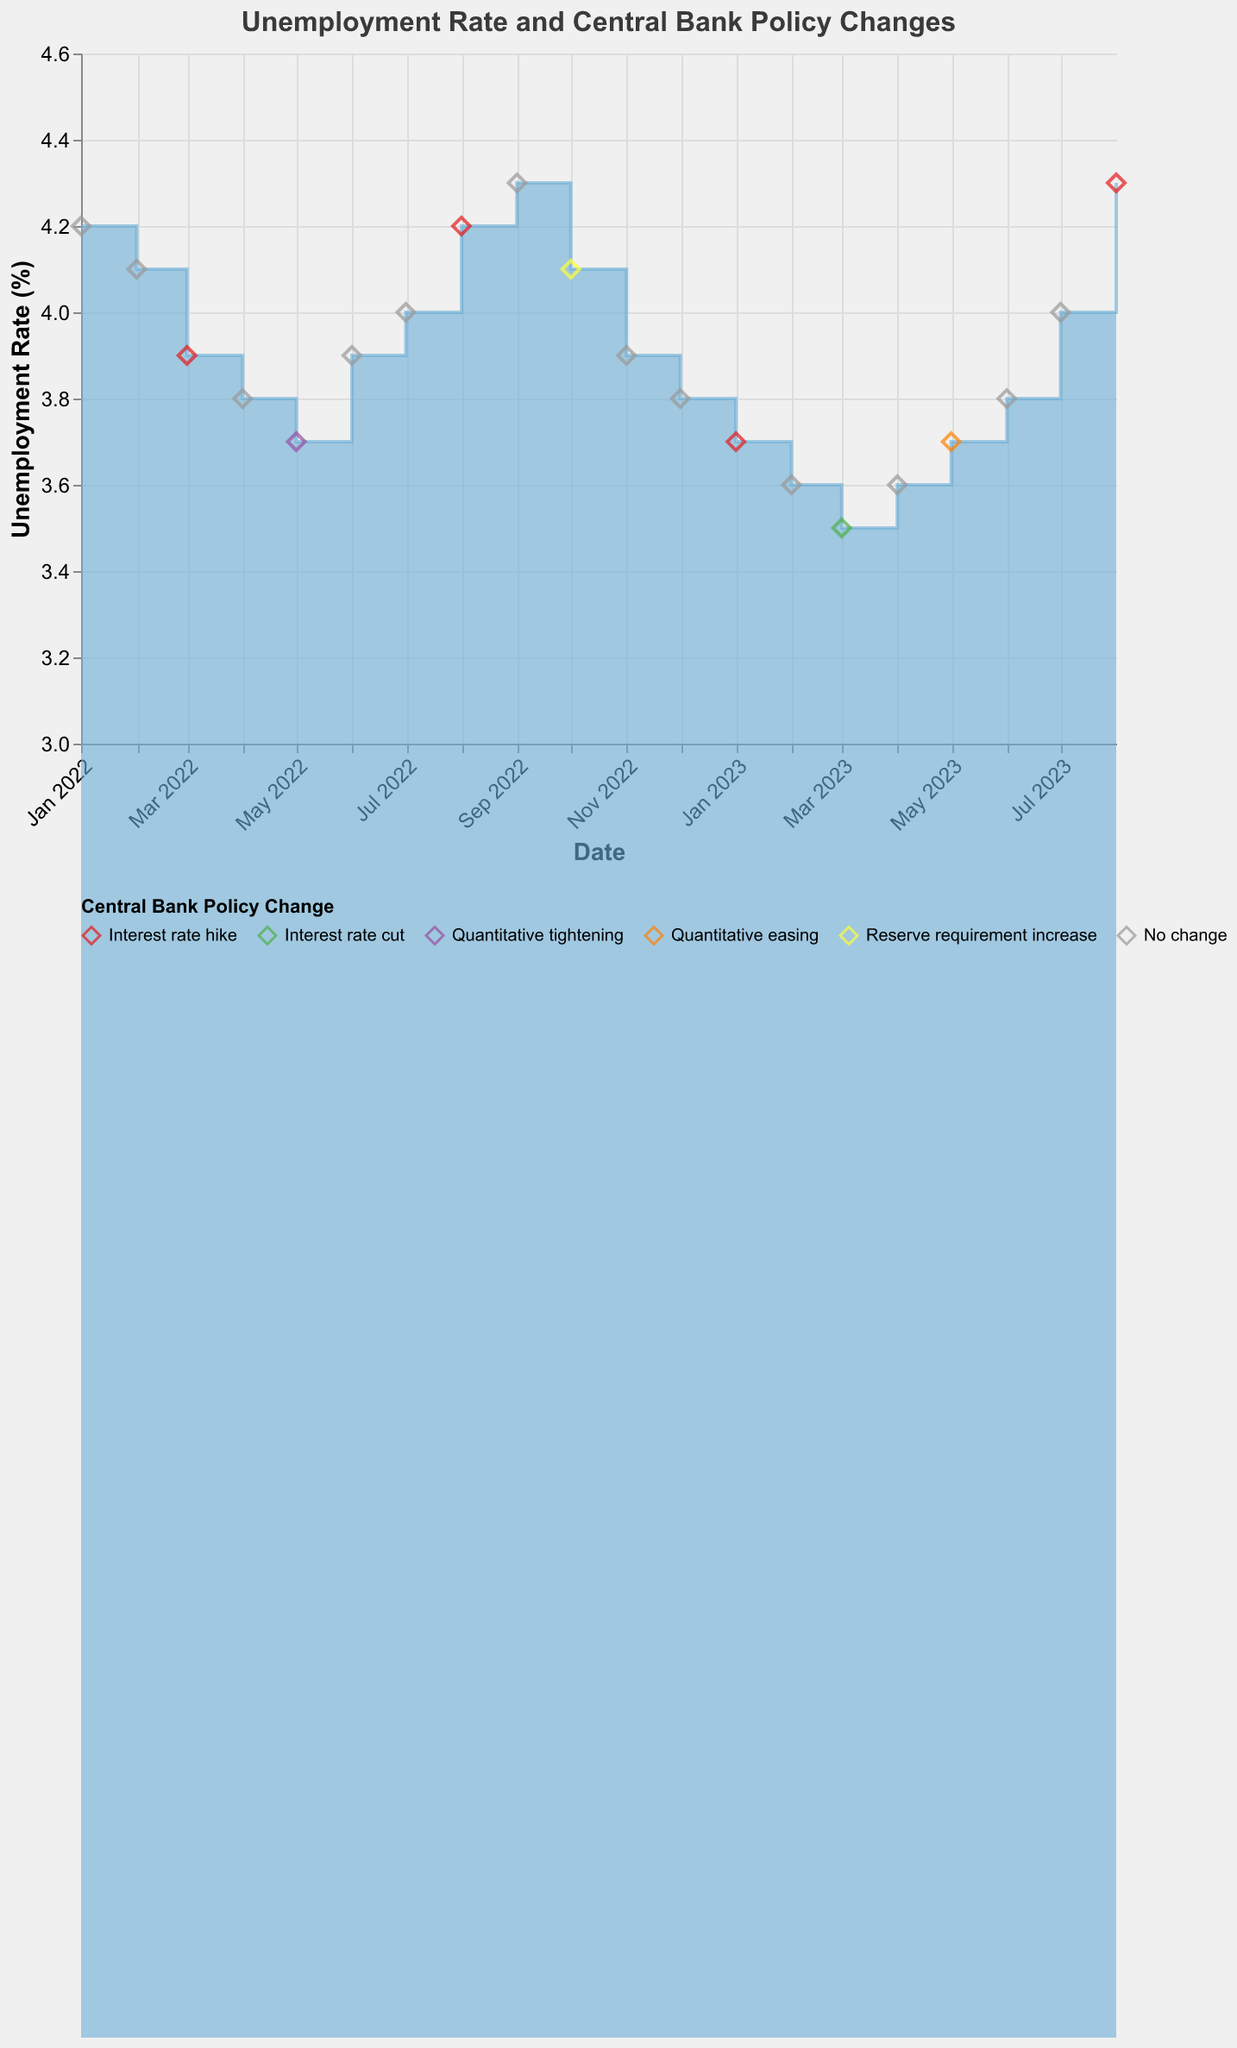What is the title of the chart? The title is usually placed at the top-center of the chart. In this case, it reads "Unemployment Rate and Central Bank Policy Changes".
Answer: Unemployment Rate and Central Bank Policy Changes What was the Unemployment Rate (%) in March 2022? To determine the unemployment rate for March 2022, locate the corresponding point on the timeline and read its vertical position from the y-axis. For March 2022, the unemployment rate is marked at 3.9%.
Answer: 3.9% Which month had the highest unemployment rate in 2023? To answer this, examine the points plotted for the year 2023 and identify the highest y-coordinate. The month with the highest unemployment rate is August 2023 at 4.3%.
Answer: August 2023 How many times did the Central Bank implement an "Interest rate hike" in the given timeframe? Look for the label "Interest rate hike" in the legend and count the corresponding diamond shapes on the chart. The Central Bank implemented an interest rate hike in March 2022, August 2022, January 2023, and August 2023, summing up to four times.
Answer: Four Did the unemployment rate increase or decrease following the "Interest rate cut" in March 2023? Examine the trend before and after March 2023. The unemployment rate decreased from 3.6% in February 2023 to 3.5% in March 2023, indicating a drop, and then it increased to 3.6% again in April 2023.
Answer: Decrease What was the unemployment rate immediately following the "Quantitative easing" policy in May 2023? First, find the policy change "Quantitative easing" in May 2023; next, look at the unemployment rate in the subsequent month, June 2023, which is 3.8%.
Answer: 3.8% Compare the unemployment rate in January 2023 with January 2022. Which was higher? Look at the values for January in both years. January 2022 has a rate of 4.2%, while January 2023 shows a rate of 3.7%. Thus, January 2022's rate is higher.
Answer: January 2022 What was the average unemployment rate in the first quarter of 2023? Average the unemployment rates for January (3.7%), February (3.6%), and March (3.5%) 2023. Sum them (3.7 + 3.6 + 3.5 = 10.8) and divide by the number of months (3). The average is 10.8/3 = 3.6.
Answer: 3.6 Did any month have an unemployment rate of exactly 4.0%? Scan the chart and find any data point aligned precisely with the 4.0% mark on the y-axis. The months that meet this criterion are July 2022 and July 2023.
Answer: Yes 